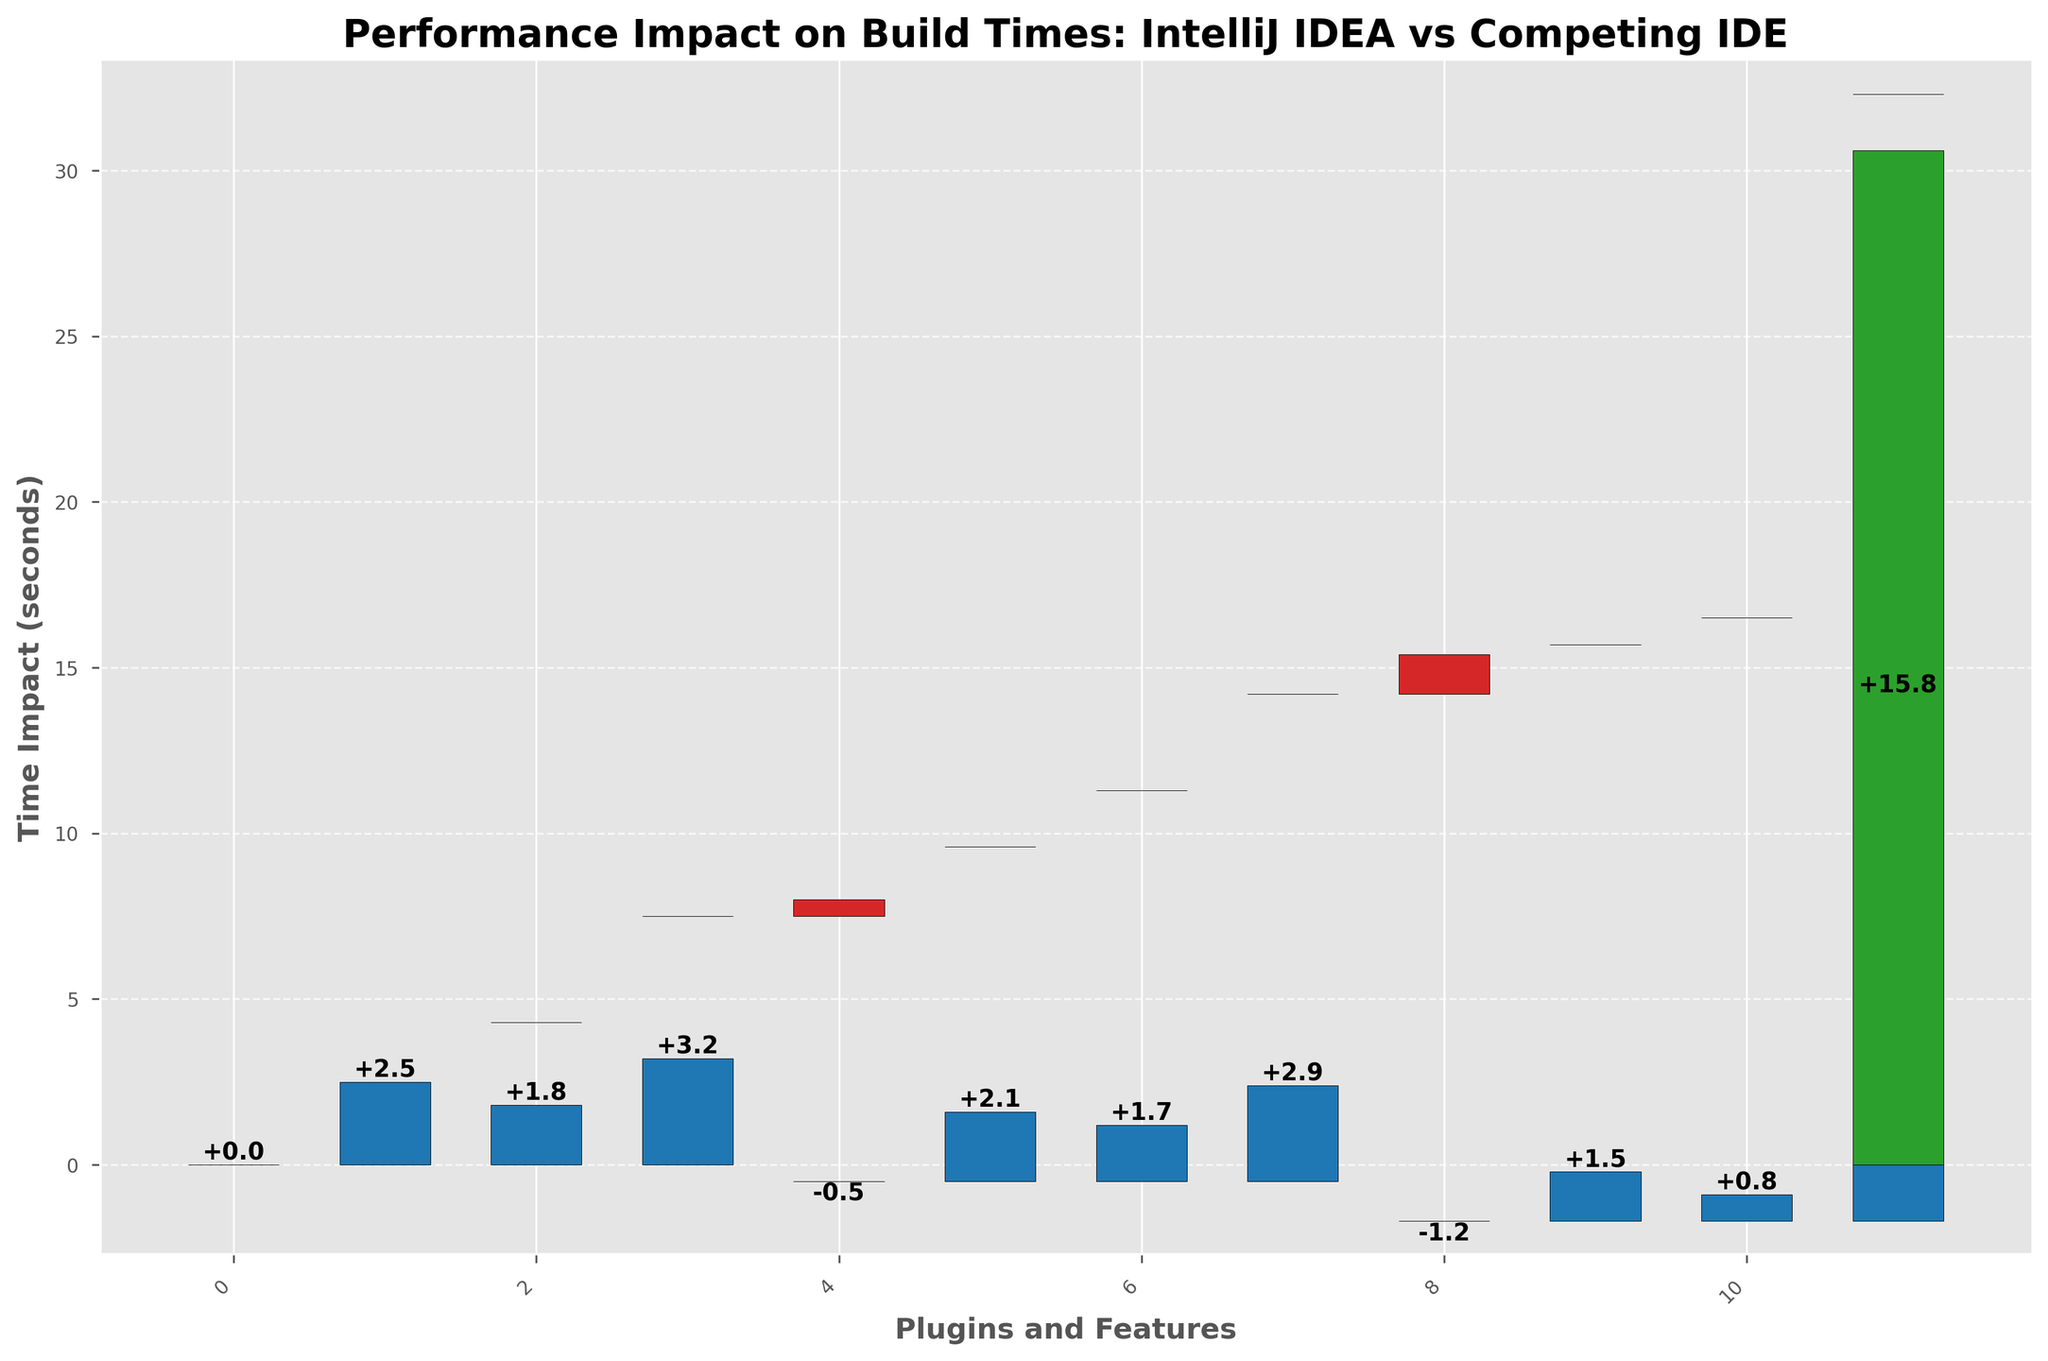what is the overall build time impact when using all the plugins? The waterfall chart adds up the incremental times for each plugin, resulting in a total build time shown as the last bar. The total build time is 15.8 seconds.
Answer: 15.8 seconds Which plugin has the highest positive impact on build time? Looking at the heights of the bars above the x-axis, the SonarLint Plugin has the tallest bar with a value of 3.2 seconds.
Answer: SonarLint Plugin Which plugin reduces the build time the most? The negative bar with the greatest magnitude represents the Eclipse JDT Plugin, with a value of -1.2 seconds.
Answer: Eclipse JDT Plugin How does the Git Integration Plugin affect build time? The Git Integration Plugin shows a negative impact by reducing the build time by 0.5 seconds. This is represented by a bar below the x-axis.
Answer: -0.5 seconds What is the sum of build time increases introduced by the JUnit and Spring Boot plugins? The JUnit Plugin adds 2.5 seconds and the Spring Boot Plugin adds 2.9 seconds. Summing these gives 2.5 + 2.9 = 5.4 seconds.
Answer: 5.4 seconds Which plugin has a smaller impact on build time, the Checkstyle Plugin or the Kotlin Plugin? The Checkstyle Plugin impacts the build time by 1.8 seconds and the Kotlin Plugin impacts it by 1.7 seconds. Comparing these values, the Kotlin Plugin has a smaller impact.
Answer: Kotlin Plugin How many plugins increase the build time? Counting the bars above the x-axis: JUnit Plugin, Checkstyle Plugin, SonarLint Plugin, Docker Plugin, Kotlin Plugin, Spring Boot Plugin, TestNG Plugin, and Maven Helper, giving a total of 8 plugins.
Answer: 8 plugins What is the difference in build time impact between the Docker and Maven Helper plugins? The Docker Plugin adds 2.1 seconds and the Maven Helper adds 0.8 seconds. The difference is 2.1 - 0.8 = 1.3 seconds.
Answer: 1.3 seconds What is the average positive impact on build time by all the plugins? Summing the positive impacts (2.5 + 1.8 + 3.2 + 2.1 + 1.7 + 2.9 + 1.5 + 0.8 = 16.5) and dividing by the number of positive-impact plugins (8) gives 16.5 / 8 = 2.06 seconds.
Answer: 2.06 seconds What's the net impact on build time from using Git Integration and Eclipse JDT plugins together? The Git Integration Plugin reduces the build time by 0.5 seconds, and the Eclipse JDT Plugin further reduces it by 1.2 seconds. Summing these, -0.5 + (-1.2) = -1.7 seconds.
Answer: -1.7 seconds 